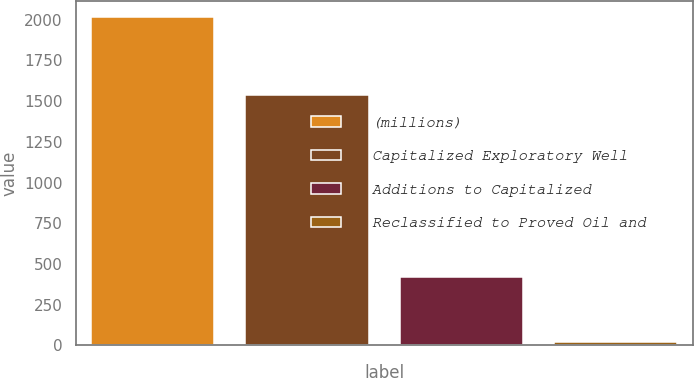Convert chart to OTSL. <chart><loc_0><loc_0><loc_500><loc_500><bar_chart><fcel>(millions)<fcel>Capitalized Exploratory Well<fcel>Additions to Capitalized<fcel>Reclassified to Proved Oil and<nl><fcel>2015<fcel>1536.6<fcel>418.2<fcel>19<nl></chart> 